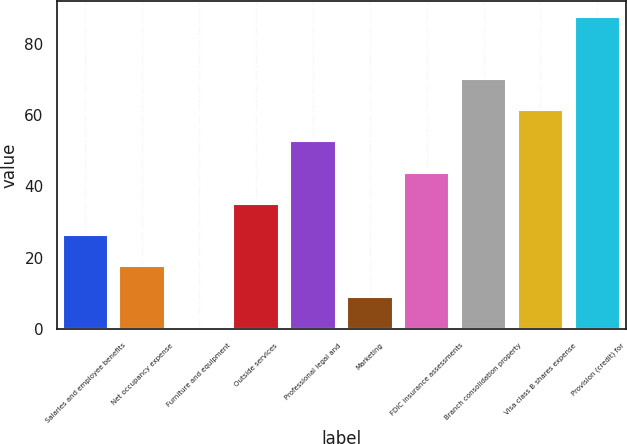Convert chart to OTSL. <chart><loc_0><loc_0><loc_500><loc_500><bar_chart><fcel>Salaries and employee benefits<fcel>Net occupancy expense<fcel>Furniture and equipment<fcel>Outside services<fcel>Professional legal and<fcel>Marketing<fcel>FDIC insurance assessments<fcel>Branch consolidation property<fcel>Visa class B shares expense<fcel>Provision (credit) for<nl><fcel>26.46<fcel>17.74<fcel>0.3<fcel>35.18<fcel>52.62<fcel>9.02<fcel>43.9<fcel>70.06<fcel>61.34<fcel>87.5<nl></chart> 